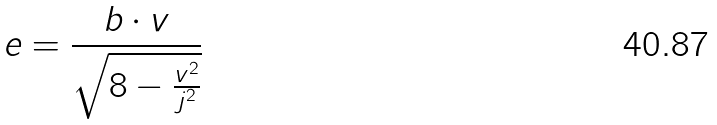<formula> <loc_0><loc_0><loc_500><loc_500>e = \frac { b \cdot v } { \sqrt { 8 - \frac { v ^ { 2 } } { j ^ { 2 } } } }</formula> 